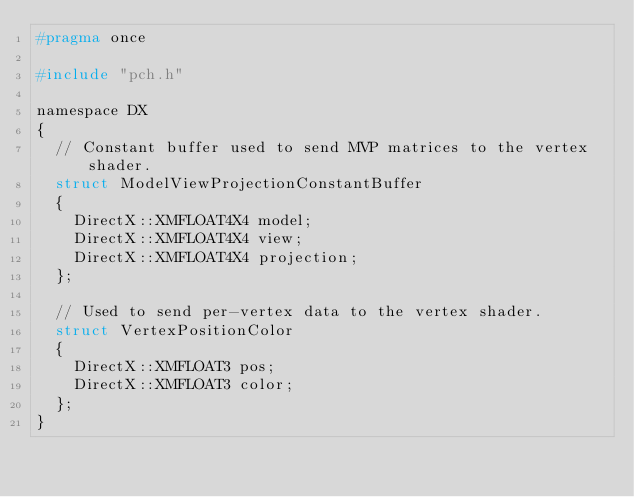Convert code to text. <code><loc_0><loc_0><loc_500><loc_500><_C_>#pragma once

#include "pch.h"

namespace DX
{
	// Constant buffer used to send MVP matrices to the vertex shader.
	struct ModelViewProjectionConstantBuffer
	{
		DirectX::XMFLOAT4X4 model;
		DirectX::XMFLOAT4X4 view;
		DirectX::XMFLOAT4X4 projection;
	};

	// Used to send per-vertex data to the vertex shader.
	struct VertexPositionColor
	{
		DirectX::XMFLOAT3 pos;
		DirectX::XMFLOAT3 color;
	};
}</code> 